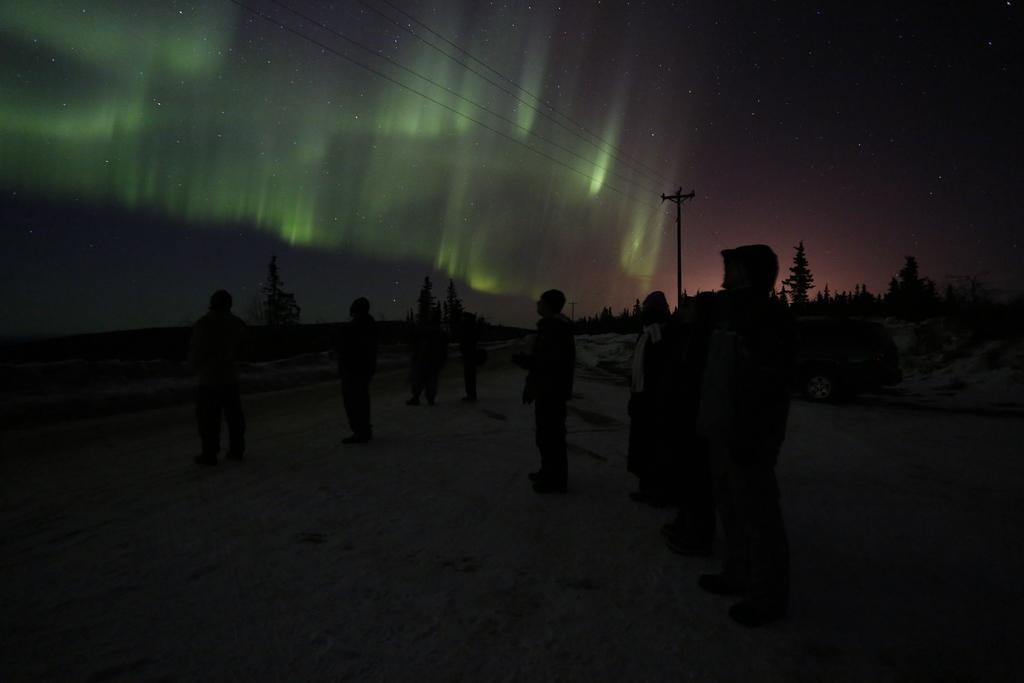Please provide a concise description of this image. In this image we can see few persons standing, there are some trees, plants, wires and an electric pole, also we can see stars in the sky. 